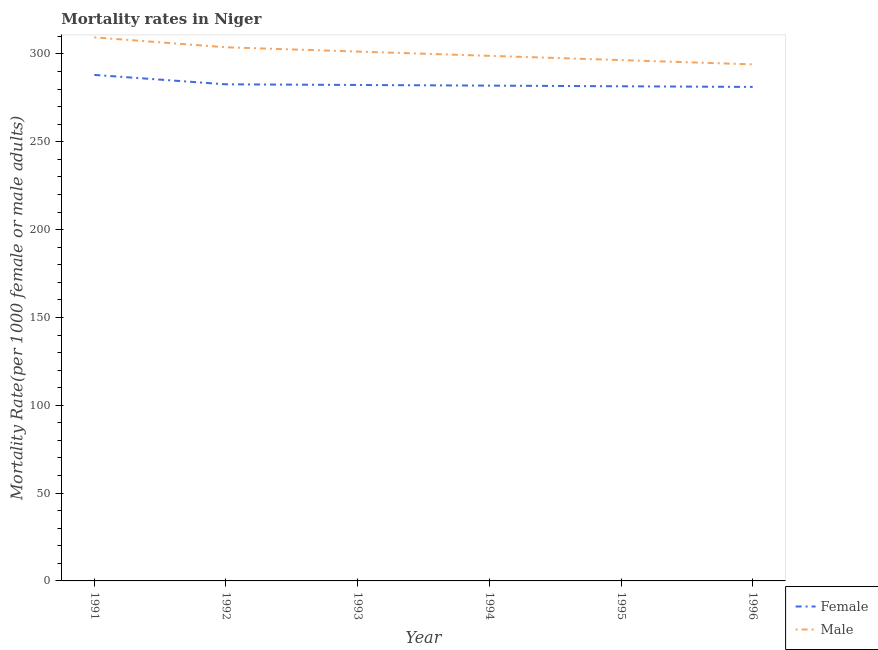Is the number of lines equal to the number of legend labels?
Offer a terse response. Yes. What is the female mortality rate in 1992?
Your response must be concise. 282.73. Across all years, what is the maximum female mortality rate?
Make the answer very short. 288.09. Across all years, what is the minimum female mortality rate?
Keep it short and to the point. 281.25. In which year was the female mortality rate maximum?
Keep it short and to the point. 1991. In which year was the male mortality rate minimum?
Keep it short and to the point. 1996. What is the total male mortality rate in the graph?
Give a very brief answer. 1804.23. What is the difference between the female mortality rate in 1991 and that in 1996?
Provide a succinct answer. 6.84. What is the difference between the male mortality rate in 1996 and the female mortality rate in 1995?
Provide a succinct answer. 12.47. What is the average female mortality rate per year?
Provide a succinct answer. 283.01. In the year 1992, what is the difference between the male mortality rate and female mortality rate?
Offer a very short reply. 21.08. What is the ratio of the female mortality rate in 1991 to that in 1995?
Provide a succinct answer. 1.02. Is the female mortality rate in 1992 less than that in 1993?
Offer a very short reply. No. Is the difference between the female mortality rate in 1991 and 1993 greater than the difference between the male mortality rate in 1991 and 1993?
Offer a terse response. No. What is the difference between the highest and the second highest male mortality rate?
Make the answer very short. 5.66. What is the difference between the highest and the lowest male mortality rate?
Your answer should be compact. 15.38. In how many years, is the female mortality rate greater than the average female mortality rate taken over all years?
Your answer should be very brief. 1. Does the male mortality rate monotonically increase over the years?
Ensure brevity in your answer.  No. How many years are there in the graph?
Your response must be concise. 6. Are the values on the major ticks of Y-axis written in scientific E-notation?
Give a very brief answer. No. Does the graph contain any zero values?
Ensure brevity in your answer.  No. Does the graph contain grids?
Your answer should be compact. No. How are the legend labels stacked?
Provide a succinct answer. Vertical. What is the title of the graph?
Provide a succinct answer. Mortality rates in Niger. What is the label or title of the Y-axis?
Make the answer very short. Mortality Rate(per 1000 female or male adults). What is the Mortality Rate(per 1000 female or male adults) of Female in 1991?
Make the answer very short. 288.09. What is the Mortality Rate(per 1000 female or male adults) in Male in 1991?
Make the answer very short. 309.47. What is the Mortality Rate(per 1000 female or male adults) in Female in 1992?
Provide a short and direct response. 282.73. What is the Mortality Rate(per 1000 female or male adults) in Male in 1992?
Offer a terse response. 303.81. What is the Mortality Rate(per 1000 female or male adults) of Female in 1993?
Your answer should be compact. 282.36. What is the Mortality Rate(per 1000 female or male adults) of Male in 1993?
Offer a very short reply. 301.38. What is the Mortality Rate(per 1000 female or male adults) of Female in 1994?
Offer a very short reply. 281.99. What is the Mortality Rate(per 1000 female or male adults) in Male in 1994?
Ensure brevity in your answer.  298.95. What is the Mortality Rate(per 1000 female or male adults) of Female in 1995?
Make the answer very short. 281.62. What is the Mortality Rate(per 1000 female or male adults) in Male in 1995?
Your answer should be very brief. 296.52. What is the Mortality Rate(per 1000 female or male adults) in Female in 1996?
Keep it short and to the point. 281.25. What is the Mortality Rate(per 1000 female or male adults) of Male in 1996?
Make the answer very short. 294.09. Across all years, what is the maximum Mortality Rate(per 1000 female or male adults) in Female?
Make the answer very short. 288.09. Across all years, what is the maximum Mortality Rate(per 1000 female or male adults) of Male?
Provide a short and direct response. 309.47. Across all years, what is the minimum Mortality Rate(per 1000 female or male adults) in Female?
Provide a succinct answer. 281.25. Across all years, what is the minimum Mortality Rate(per 1000 female or male adults) in Male?
Provide a short and direct response. 294.09. What is the total Mortality Rate(per 1000 female or male adults) of Female in the graph?
Provide a succinct answer. 1698.03. What is the total Mortality Rate(per 1000 female or male adults) of Male in the graph?
Ensure brevity in your answer.  1804.23. What is the difference between the Mortality Rate(per 1000 female or male adults) of Female in 1991 and that in 1992?
Ensure brevity in your answer.  5.35. What is the difference between the Mortality Rate(per 1000 female or male adults) of Male in 1991 and that in 1992?
Provide a short and direct response. 5.66. What is the difference between the Mortality Rate(per 1000 female or male adults) of Female in 1991 and that in 1993?
Offer a very short reply. 5.73. What is the difference between the Mortality Rate(per 1000 female or male adults) in Male in 1991 and that in 1993?
Offer a very short reply. 8.09. What is the difference between the Mortality Rate(per 1000 female or male adults) in Female in 1991 and that in 1994?
Provide a short and direct response. 6.1. What is the difference between the Mortality Rate(per 1000 female or male adults) in Male in 1991 and that in 1994?
Your answer should be compact. 10.52. What is the difference between the Mortality Rate(per 1000 female or male adults) of Female in 1991 and that in 1995?
Make the answer very short. 6.47. What is the difference between the Mortality Rate(per 1000 female or male adults) of Male in 1991 and that in 1995?
Make the answer very short. 12.95. What is the difference between the Mortality Rate(per 1000 female or male adults) of Female in 1991 and that in 1996?
Make the answer very short. 6.84. What is the difference between the Mortality Rate(per 1000 female or male adults) of Male in 1991 and that in 1996?
Your response must be concise. 15.38. What is the difference between the Mortality Rate(per 1000 female or male adults) of Female in 1992 and that in 1993?
Provide a short and direct response. 0.37. What is the difference between the Mortality Rate(per 1000 female or male adults) in Male in 1992 and that in 1993?
Your answer should be compact. 2.43. What is the difference between the Mortality Rate(per 1000 female or male adults) of Female in 1992 and that in 1994?
Offer a very short reply. 0.74. What is the difference between the Mortality Rate(per 1000 female or male adults) in Male in 1992 and that in 1994?
Offer a terse response. 4.86. What is the difference between the Mortality Rate(per 1000 female or male adults) of Female in 1992 and that in 1995?
Your answer should be compact. 1.11. What is the difference between the Mortality Rate(per 1000 female or male adults) of Male in 1992 and that in 1995?
Offer a very short reply. 7.29. What is the difference between the Mortality Rate(per 1000 female or male adults) of Female in 1992 and that in 1996?
Make the answer very short. 1.49. What is the difference between the Mortality Rate(per 1000 female or male adults) of Male in 1992 and that in 1996?
Your answer should be very brief. 9.72. What is the difference between the Mortality Rate(per 1000 female or male adults) of Female in 1993 and that in 1994?
Your answer should be very brief. 0.37. What is the difference between the Mortality Rate(per 1000 female or male adults) of Male in 1993 and that in 1994?
Offer a terse response. 2.43. What is the difference between the Mortality Rate(per 1000 female or male adults) in Female in 1993 and that in 1995?
Provide a succinct answer. 0.74. What is the difference between the Mortality Rate(per 1000 female or male adults) of Male in 1993 and that in 1995?
Offer a terse response. 4.86. What is the difference between the Mortality Rate(per 1000 female or male adults) of Female in 1993 and that in 1996?
Your answer should be compact. 1.11. What is the difference between the Mortality Rate(per 1000 female or male adults) of Male in 1993 and that in 1996?
Give a very brief answer. 7.29. What is the difference between the Mortality Rate(per 1000 female or male adults) in Female in 1994 and that in 1995?
Your answer should be compact. 0.37. What is the difference between the Mortality Rate(per 1000 female or male adults) of Male in 1994 and that in 1995?
Offer a terse response. 2.43. What is the difference between the Mortality Rate(per 1000 female or male adults) in Female in 1994 and that in 1996?
Your answer should be very brief. 0.74. What is the difference between the Mortality Rate(per 1000 female or male adults) of Male in 1994 and that in 1996?
Your answer should be compact. 4.86. What is the difference between the Mortality Rate(per 1000 female or male adults) in Female in 1995 and that in 1996?
Ensure brevity in your answer.  0.37. What is the difference between the Mortality Rate(per 1000 female or male adults) of Male in 1995 and that in 1996?
Provide a succinct answer. 2.43. What is the difference between the Mortality Rate(per 1000 female or male adults) of Female in 1991 and the Mortality Rate(per 1000 female or male adults) of Male in 1992?
Provide a short and direct response. -15.73. What is the difference between the Mortality Rate(per 1000 female or male adults) of Female in 1991 and the Mortality Rate(per 1000 female or male adults) of Male in 1993?
Your answer should be compact. -13.3. What is the difference between the Mortality Rate(per 1000 female or male adults) of Female in 1991 and the Mortality Rate(per 1000 female or male adults) of Male in 1994?
Your answer should be very brief. -10.87. What is the difference between the Mortality Rate(per 1000 female or male adults) of Female in 1991 and the Mortality Rate(per 1000 female or male adults) of Male in 1995?
Ensure brevity in your answer.  -8.44. What is the difference between the Mortality Rate(per 1000 female or male adults) of Female in 1991 and the Mortality Rate(per 1000 female or male adults) of Male in 1996?
Give a very brief answer. -6. What is the difference between the Mortality Rate(per 1000 female or male adults) in Female in 1992 and the Mortality Rate(per 1000 female or male adults) in Male in 1993?
Give a very brief answer. -18.65. What is the difference between the Mortality Rate(per 1000 female or male adults) in Female in 1992 and the Mortality Rate(per 1000 female or male adults) in Male in 1994?
Keep it short and to the point. -16.22. What is the difference between the Mortality Rate(per 1000 female or male adults) in Female in 1992 and the Mortality Rate(per 1000 female or male adults) in Male in 1995?
Your answer should be very brief. -13.79. What is the difference between the Mortality Rate(per 1000 female or male adults) of Female in 1992 and the Mortality Rate(per 1000 female or male adults) of Male in 1996?
Your answer should be very brief. -11.36. What is the difference between the Mortality Rate(per 1000 female or male adults) of Female in 1993 and the Mortality Rate(per 1000 female or male adults) of Male in 1994?
Offer a very short reply. -16.59. What is the difference between the Mortality Rate(per 1000 female or male adults) of Female in 1993 and the Mortality Rate(per 1000 female or male adults) of Male in 1995?
Keep it short and to the point. -14.16. What is the difference between the Mortality Rate(per 1000 female or male adults) of Female in 1993 and the Mortality Rate(per 1000 female or male adults) of Male in 1996?
Keep it short and to the point. -11.73. What is the difference between the Mortality Rate(per 1000 female or male adults) in Female in 1994 and the Mortality Rate(per 1000 female or male adults) in Male in 1995?
Your answer should be compact. -14.53. What is the difference between the Mortality Rate(per 1000 female or male adults) of Female in 1994 and the Mortality Rate(per 1000 female or male adults) of Male in 1996?
Provide a succinct answer. -12.1. What is the difference between the Mortality Rate(per 1000 female or male adults) of Female in 1995 and the Mortality Rate(per 1000 female or male adults) of Male in 1996?
Your answer should be very brief. -12.47. What is the average Mortality Rate(per 1000 female or male adults) of Female per year?
Your answer should be very brief. 283. What is the average Mortality Rate(per 1000 female or male adults) in Male per year?
Make the answer very short. 300.7. In the year 1991, what is the difference between the Mortality Rate(per 1000 female or male adults) in Female and Mortality Rate(per 1000 female or male adults) in Male?
Ensure brevity in your answer.  -21.39. In the year 1992, what is the difference between the Mortality Rate(per 1000 female or male adults) of Female and Mortality Rate(per 1000 female or male adults) of Male?
Offer a very short reply. -21.08. In the year 1993, what is the difference between the Mortality Rate(per 1000 female or male adults) in Female and Mortality Rate(per 1000 female or male adults) in Male?
Provide a short and direct response. -19.02. In the year 1994, what is the difference between the Mortality Rate(per 1000 female or male adults) of Female and Mortality Rate(per 1000 female or male adults) of Male?
Make the answer very short. -16.96. In the year 1995, what is the difference between the Mortality Rate(per 1000 female or male adults) in Female and Mortality Rate(per 1000 female or male adults) in Male?
Provide a succinct answer. -14.9. In the year 1996, what is the difference between the Mortality Rate(per 1000 female or male adults) of Female and Mortality Rate(per 1000 female or male adults) of Male?
Make the answer very short. -12.85. What is the ratio of the Mortality Rate(per 1000 female or male adults) in Female in 1991 to that in 1992?
Your response must be concise. 1.02. What is the ratio of the Mortality Rate(per 1000 female or male adults) in Male in 1991 to that in 1992?
Your answer should be very brief. 1.02. What is the ratio of the Mortality Rate(per 1000 female or male adults) in Female in 1991 to that in 1993?
Ensure brevity in your answer.  1.02. What is the ratio of the Mortality Rate(per 1000 female or male adults) of Male in 1991 to that in 1993?
Offer a terse response. 1.03. What is the ratio of the Mortality Rate(per 1000 female or male adults) of Female in 1991 to that in 1994?
Your response must be concise. 1.02. What is the ratio of the Mortality Rate(per 1000 female or male adults) of Male in 1991 to that in 1994?
Your answer should be compact. 1.04. What is the ratio of the Mortality Rate(per 1000 female or male adults) of Female in 1991 to that in 1995?
Provide a succinct answer. 1.02. What is the ratio of the Mortality Rate(per 1000 female or male adults) of Male in 1991 to that in 1995?
Your response must be concise. 1.04. What is the ratio of the Mortality Rate(per 1000 female or male adults) of Female in 1991 to that in 1996?
Keep it short and to the point. 1.02. What is the ratio of the Mortality Rate(per 1000 female or male adults) of Male in 1991 to that in 1996?
Make the answer very short. 1.05. What is the ratio of the Mortality Rate(per 1000 female or male adults) of Female in 1992 to that in 1993?
Your answer should be very brief. 1. What is the ratio of the Mortality Rate(per 1000 female or male adults) of Male in 1992 to that in 1993?
Provide a succinct answer. 1.01. What is the ratio of the Mortality Rate(per 1000 female or male adults) in Female in 1992 to that in 1994?
Provide a short and direct response. 1. What is the ratio of the Mortality Rate(per 1000 female or male adults) of Male in 1992 to that in 1994?
Offer a very short reply. 1.02. What is the ratio of the Mortality Rate(per 1000 female or male adults) of Male in 1992 to that in 1995?
Keep it short and to the point. 1.02. What is the ratio of the Mortality Rate(per 1000 female or male adults) of Female in 1992 to that in 1996?
Provide a succinct answer. 1.01. What is the ratio of the Mortality Rate(per 1000 female or male adults) in Male in 1992 to that in 1996?
Provide a succinct answer. 1.03. What is the ratio of the Mortality Rate(per 1000 female or male adults) in Female in 1993 to that in 1994?
Offer a very short reply. 1. What is the ratio of the Mortality Rate(per 1000 female or male adults) in Male in 1993 to that in 1994?
Offer a terse response. 1.01. What is the ratio of the Mortality Rate(per 1000 female or male adults) of Male in 1993 to that in 1995?
Your answer should be very brief. 1.02. What is the ratio of the Mortality Rate(per 1000 female or male adults) of Male in 1993 to that in 1996?
Ensure brevity in your answer.  1.02. What is the ratio of the Mortality Rate(per 1000 female or male adults) of Female in 1994 to that in 1995?
Keep it short and to the point. 1. What is the ratio of the Mortality Rate(per 1000 female or male adults) of Male in 1994 to that in 1995?
Make the answer very short. 1.01. What is the ratio of the Mortality Rate(per 1000 female or male adults) in Male in 1994 to that in 1996?
Your answer should be compact. 1.02. What is the ratio of the Mortality Rate(per 1000 female or male adults) of Female in 1995 to that in 1996?
Your response must be concise. 1. What is the ratio of the Mortality Rate(per 1000 female or male adults) in Male in 1995 to that in 1996?
Your response must be concise. 1.01. What is the difference between the highest and the second highest Mortality Rate(per 1000 female or male adults) in Female?
Your response must be concise. 5.35. What is the difference between the highest and the second highest Mortality Rate(per 1000 female or male adults) in Male?
Ensure brevity in your answer.  5.66. What is the difference between the highest and the lowest Mortality Rate(per 1000 female or male adults) in Female?
Give a very brief answer. 6.84. What is the difference between the highest and the lowest Mortality Rate(per 1000 female or male adults) in Male?
Provide a short and direct response. 15.38. 